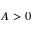Convert formula to latex. <formula><loc_0><loc_0><loc_500><loc_500>A > 0</formula> 